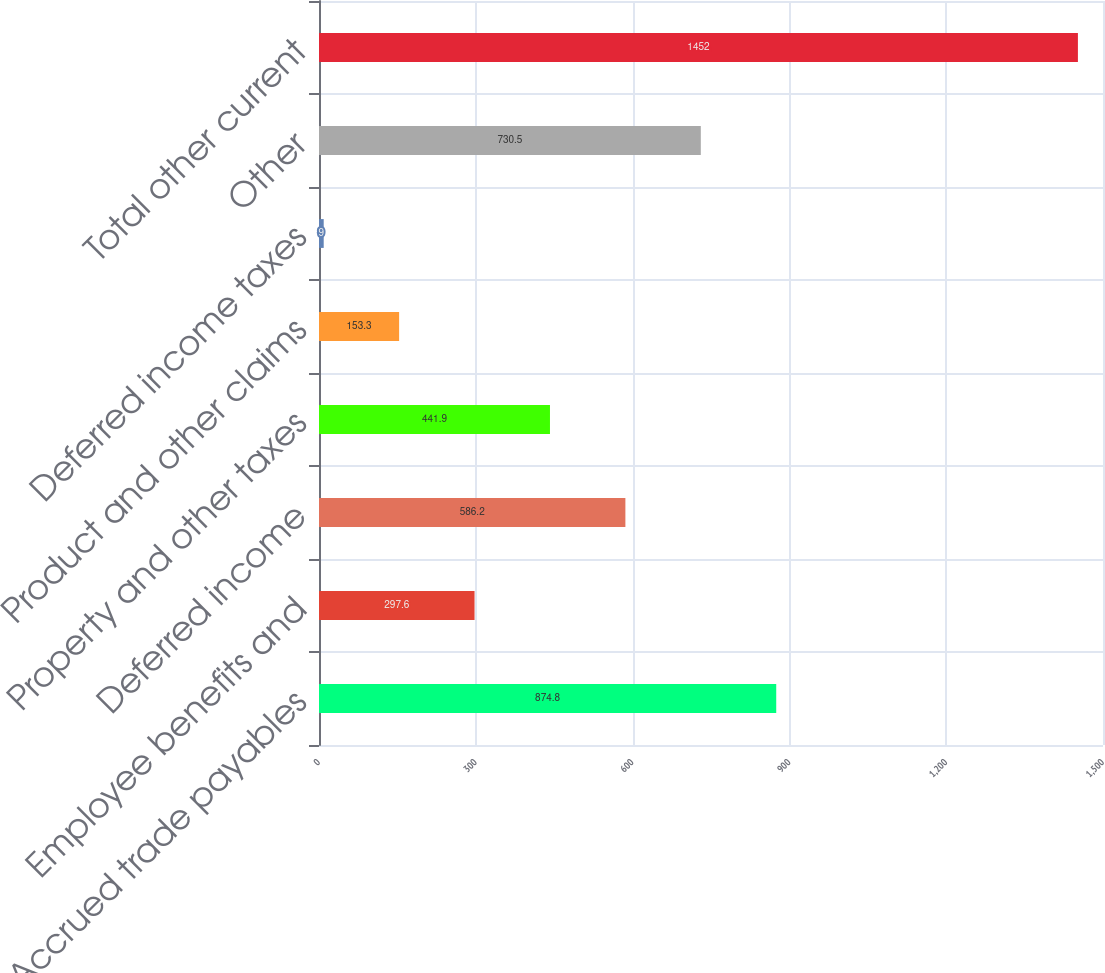Convert chart. <chart><loc_0><loc_0><loc_500><loc_500><bar_chart><fcel>Accrued trade payables<fcel>Employee benefits and<fcel>Deferred income<fcel>Property and other taxes<fcel>Product and other claims<fcel>Deferred income taxes<fcel>Other<fcel>Total other current<nl><fcel>874.8<fcel>297.6<fcel>586.2<fcel>441.9<fcel>153.3<fcel>9<fcel>730.5<fcel>1452<nl></chart> 